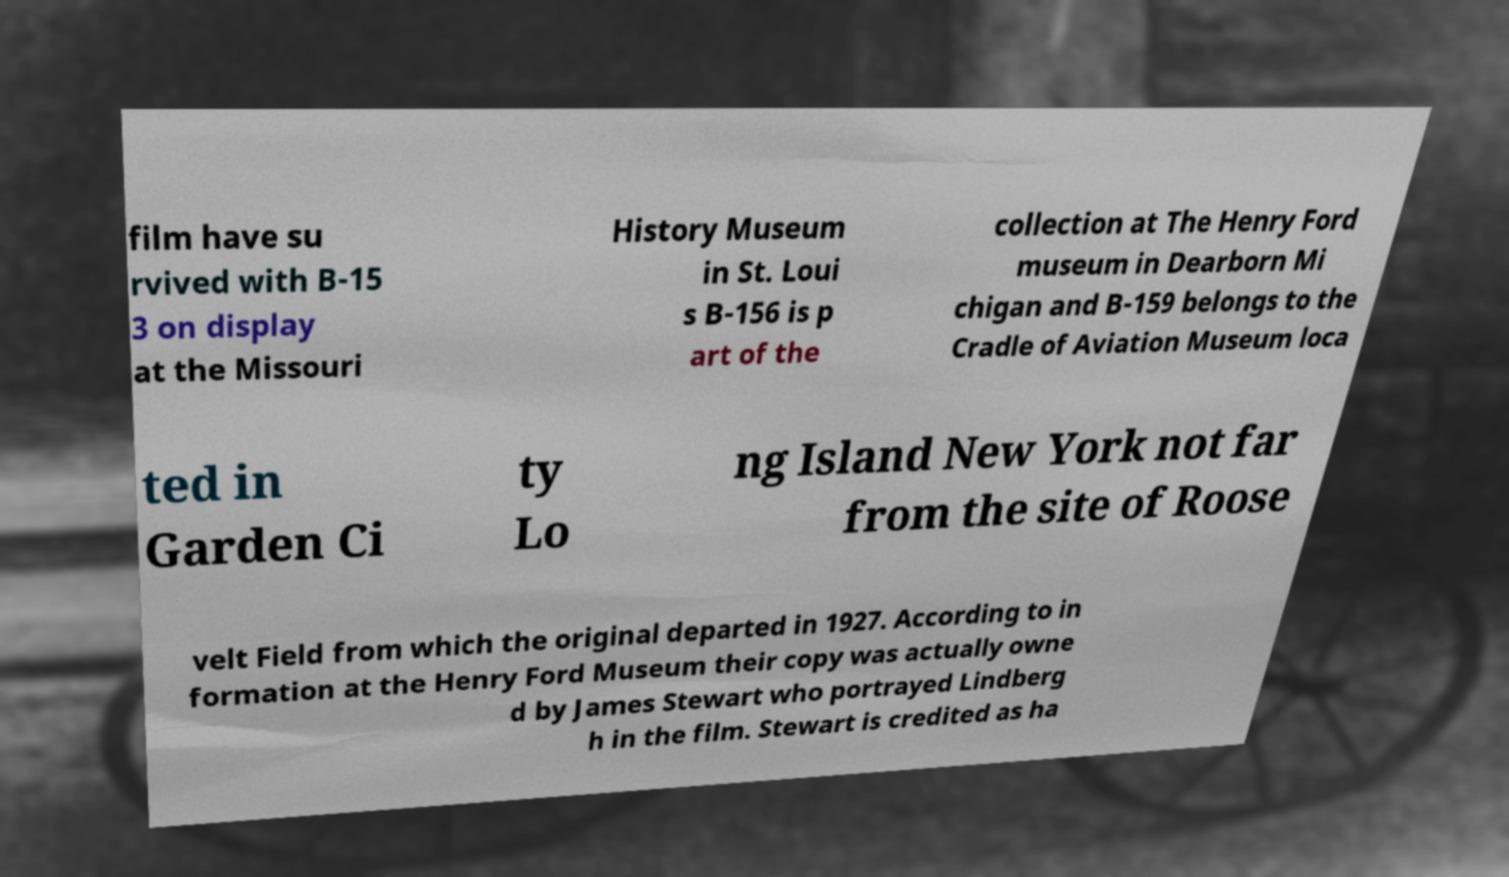Could you extract and type out the text from this image? film have su rvived with B-15 3 on display at the Missouri History Museum in St. Loui s B-156 is p art of the collection at The Henry Ford museum in Dearborn Mi chigan and B-159 belongs to the Cradle of Aviation Museum loca ted in Garden Ci ty Lo ng Island New York not far from the site of Roose velt Field from which the original departed in 1927. According to in formation at the Henry Ford Museum their copy was actually owne d by James Stewart who portrayed Lindberg h in the film. Stewart is credited as ha 